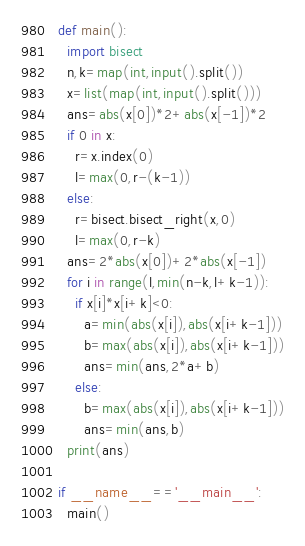<code> <loc_0><loc_0><loc_500><loc_500><_Python_>def main():
  import bisect
  n,k=map(int,input().split())
  x=list(map(int,input().split()))
  ans=abs(x[0])*2+abs(x[-1])*2
  if 0 in x:
    r=x.index(0)
    l=max(0,r-(k-1))
  else:
    r=bisect.bisect_right(x,0)
    l=max(0,r-k)
  ans=2*abs(x[0])+2*abs(x[-1])
  for i in range(l,min(n-k,l+k-1)):
    if x[i]*x[i+k]<0:
      a=min(abs(x[i]),abs(x[i+k-1]))
      b=max(abs(x[i]),abs(x[i+k-1]))
      ans=min(ans,2*a+b)
    else:
      b=max(abs(x[i]),abs(x[i+k-1]))
      ans=min(ans,b)
  print(ans)

if __name__=='__main__':
  main()</code> 